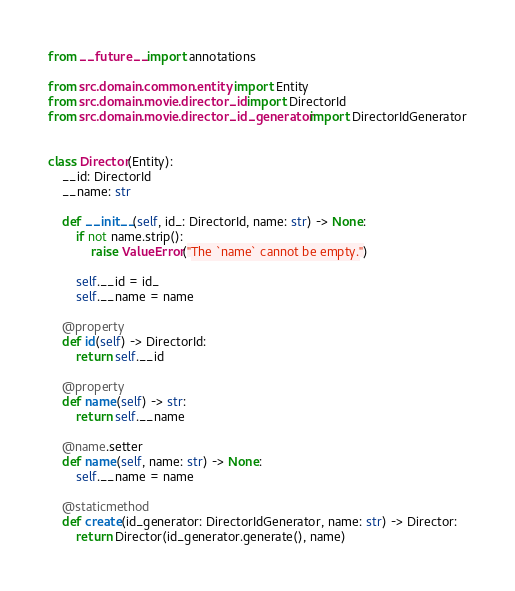<code> <loc_0><loc_0><loc_500><loc_500><_Python_>from __future__ import annotations

from src.domain.common.entity import Entity
from src.domain.movie.director_id import DirectorId
from src.domain.movie.director_id_generator import DirectorIdGenerator


class Director(Entity):
    __id: DirectorId
    __name: str

    def __init__(self, id_: DirectorId, name: str) -> None:
        if not name.strip():
            raise ValueError("The `name` cannot be empty.")

        self.__id = id_
        self.__name = name

    @property
    def id(self) -> DirectorId:
        return self.__id

    @property
    def name(self) -> str:
        return self.__name

    @name.setter
    def name(self, name: str) -> None:
        self.__name = name

    @staticmethod
    def create(id_generator: DirectorIdGenerator, name: str) -> Director:
        return Director(id_generator.generate(), name)
</code> 